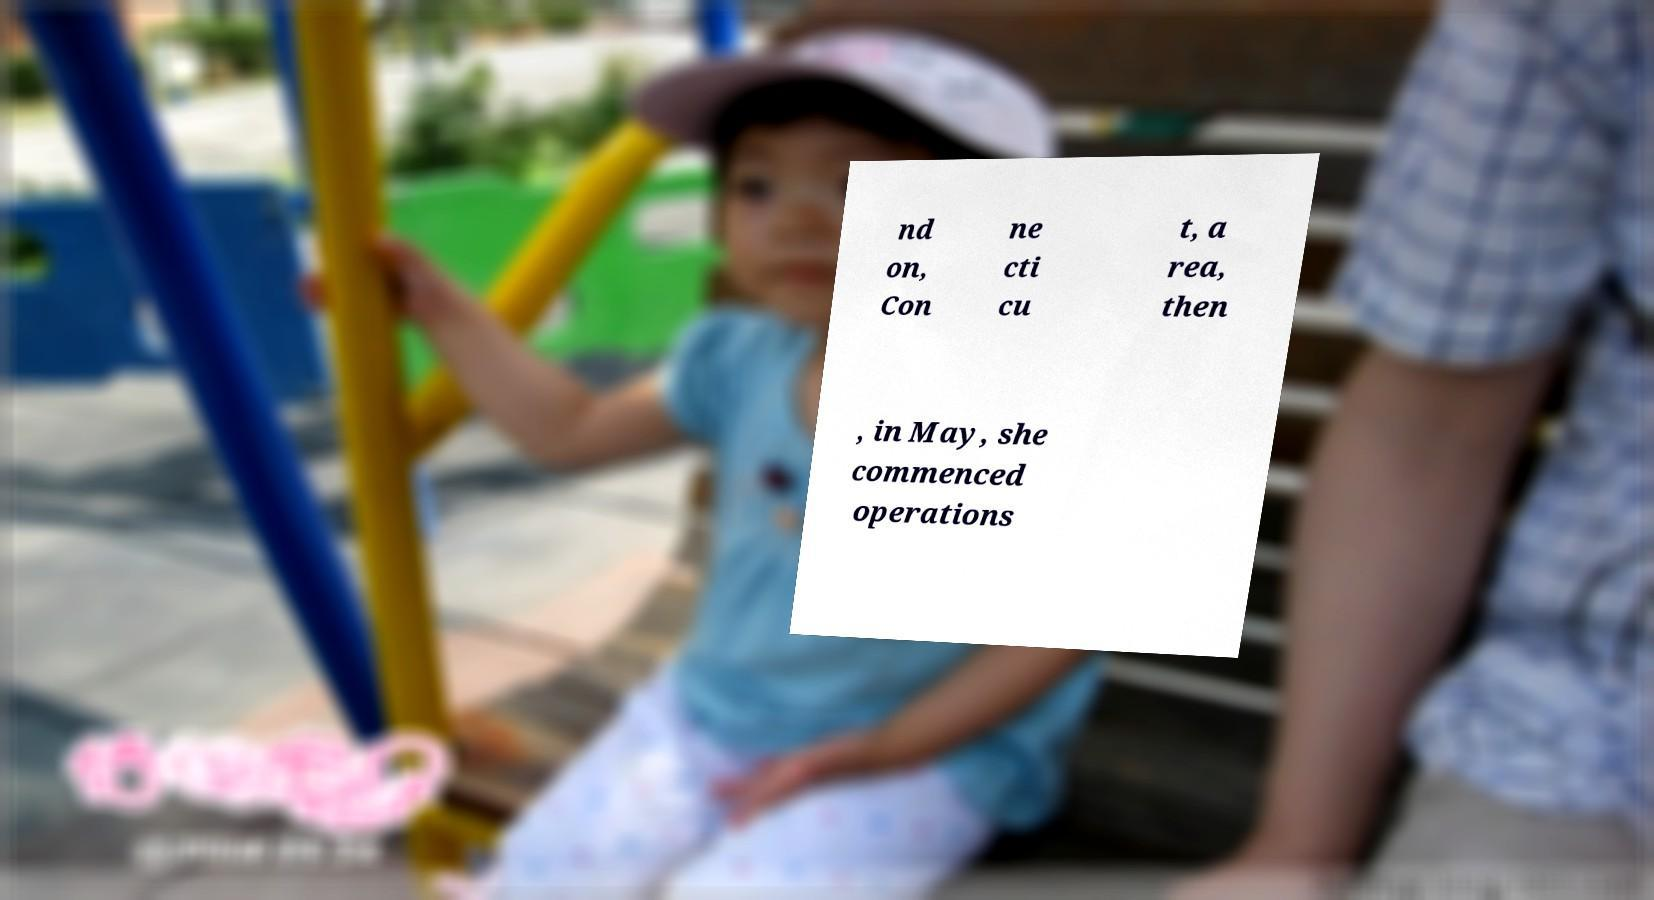For documentation purposes, I need the text within this image transcribed. Could you provide that? nd on, Con ne cti cu t, a rea, then , in May, she commenced operations 